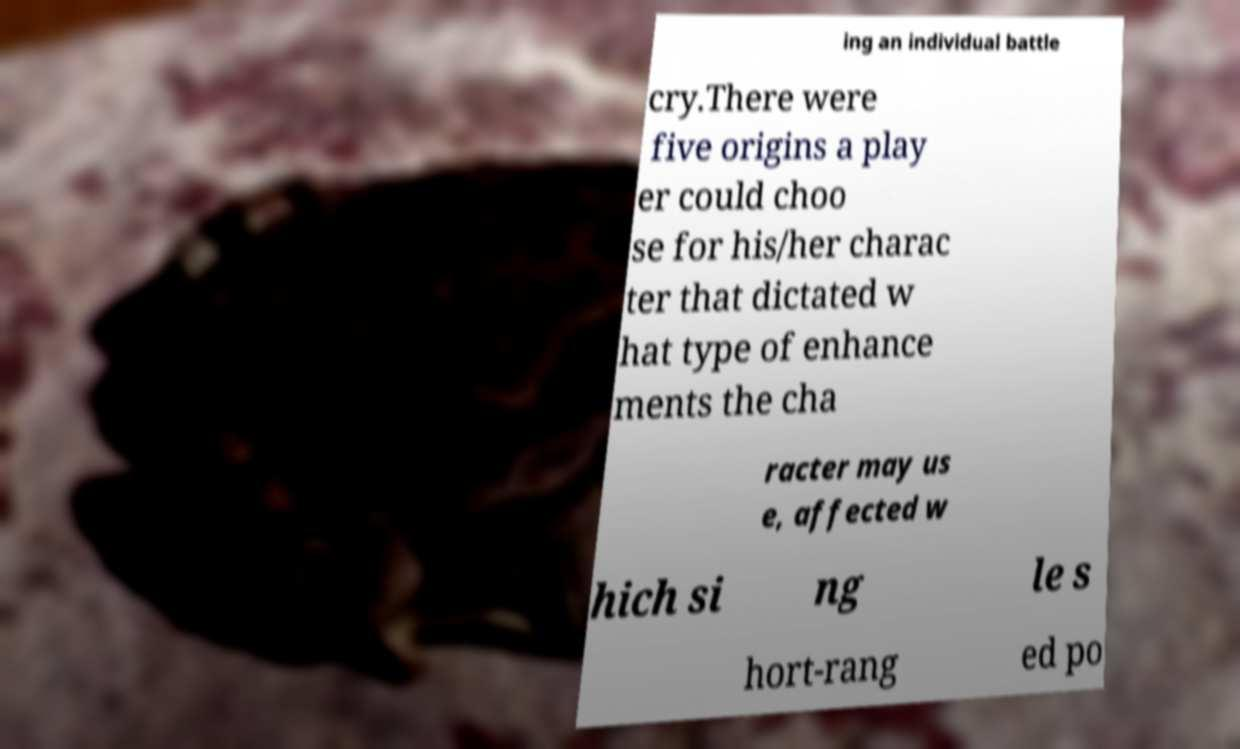Can you read and provide the text displayed in the image?This photo seems to have some interesting text. Can you extract and type it out for me? ing an individual battle cry.There were five origins a play er could choo se for his/her charac ter that dictated w hat type of enhance ments the cha racter may us e, affected w hich si ng le s hort-rang ed po 